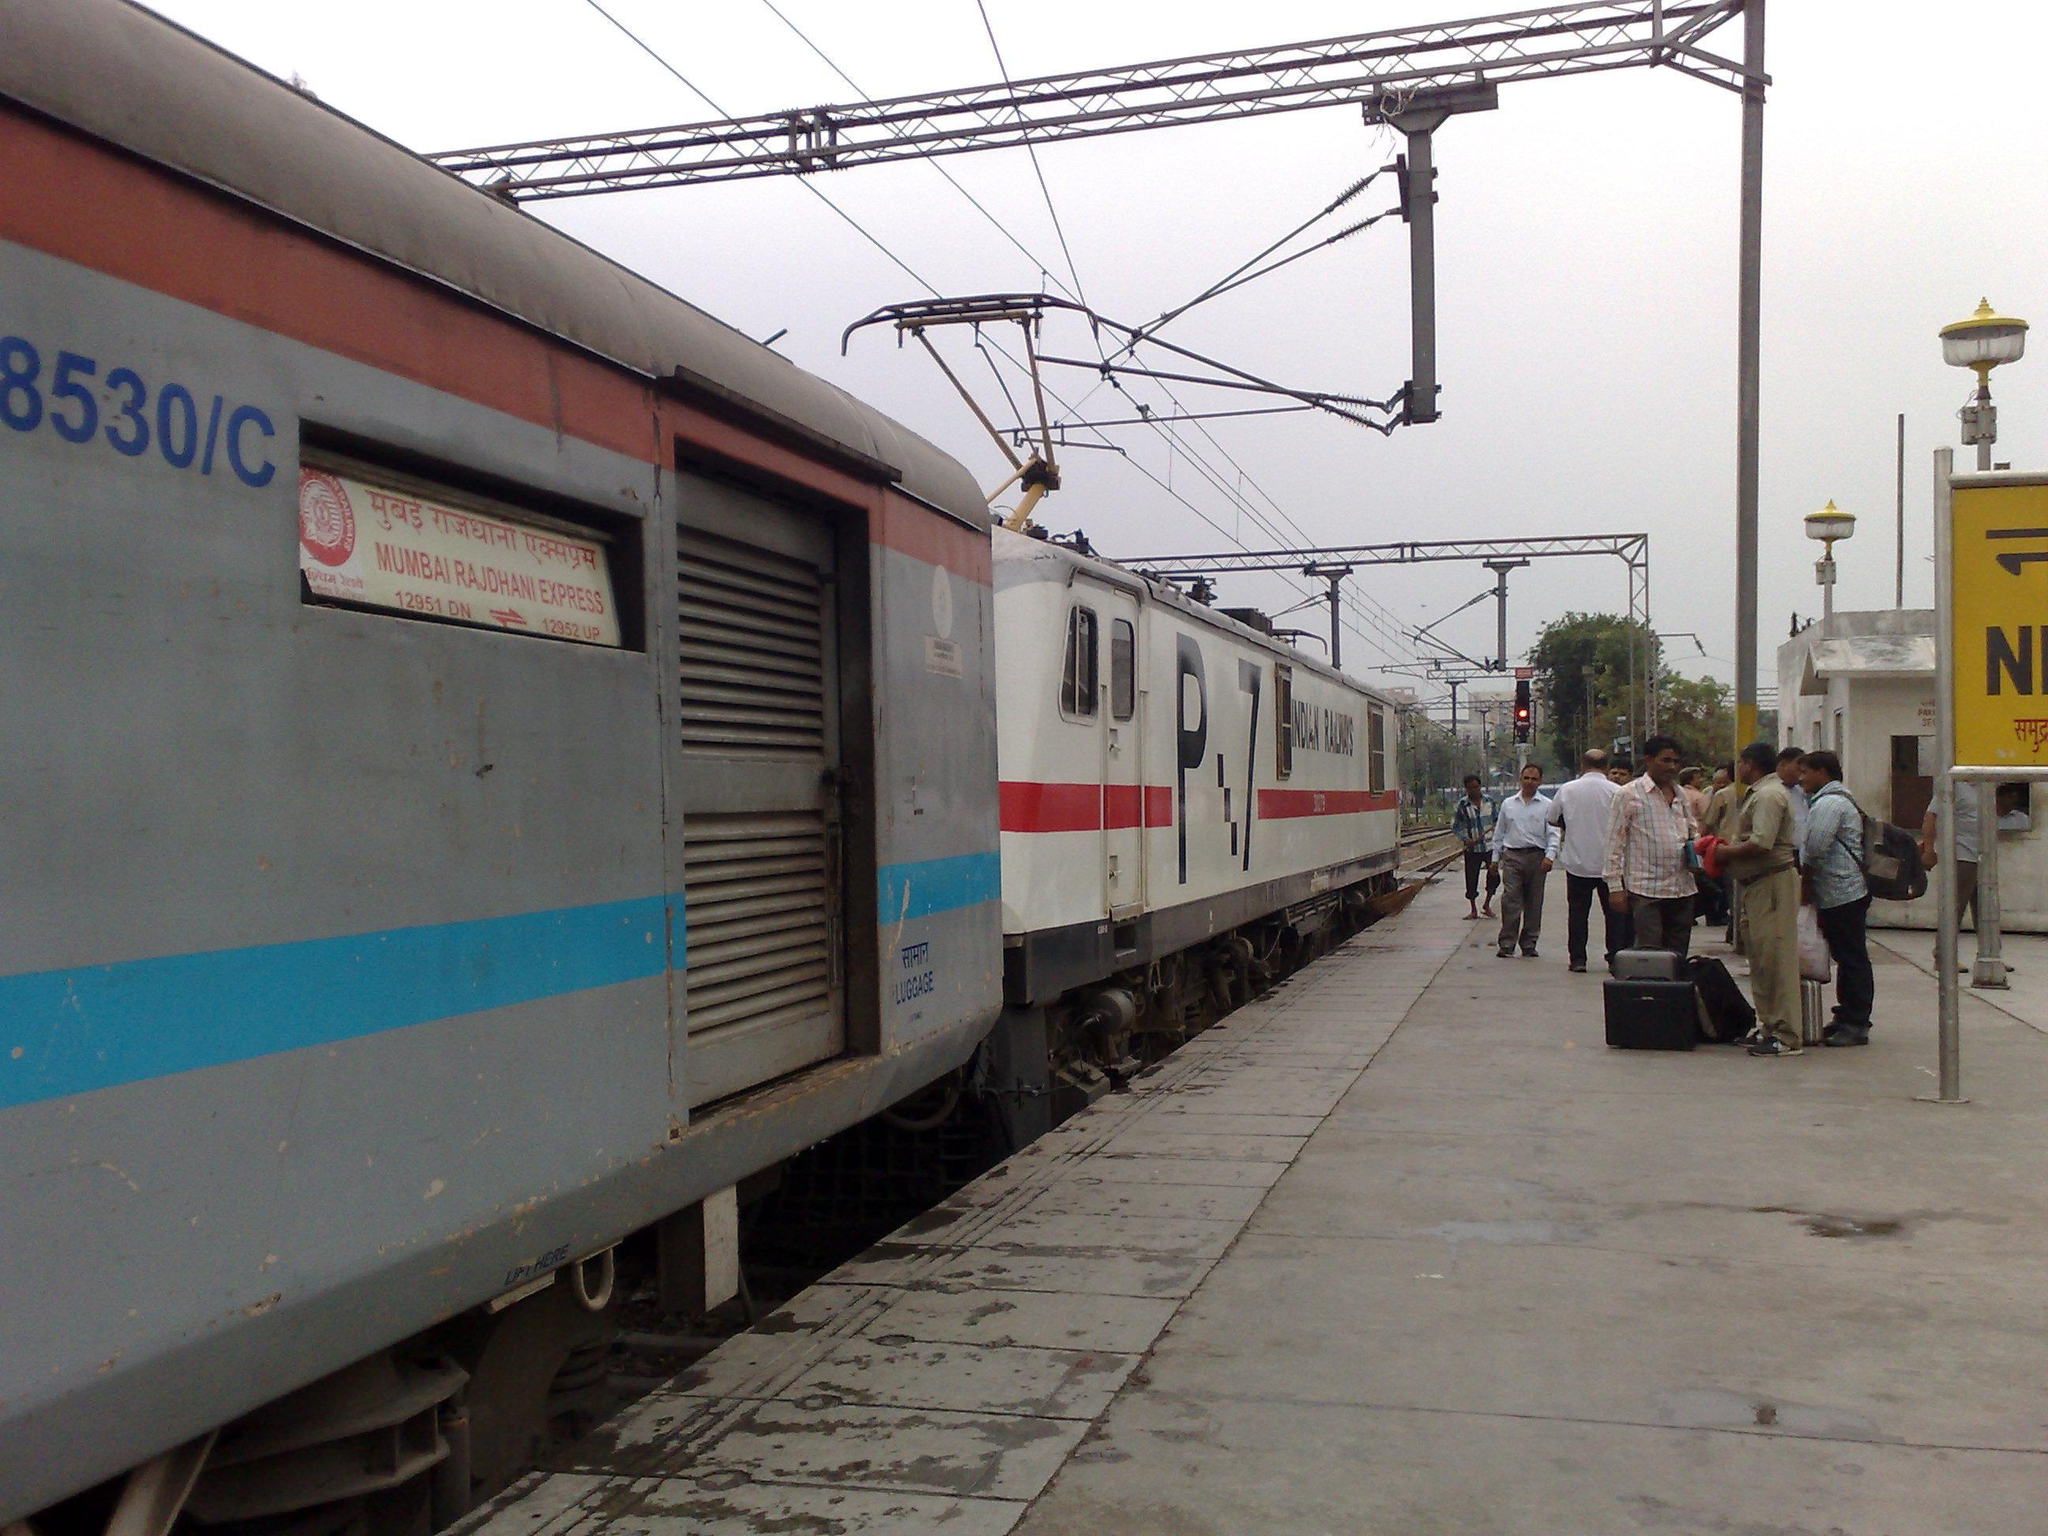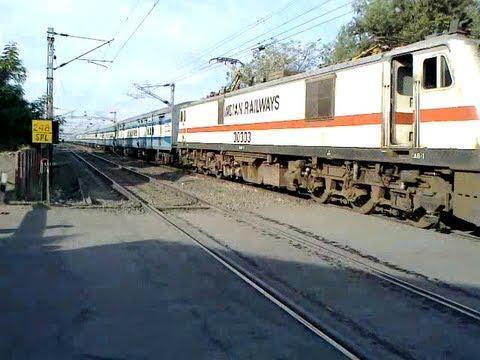The first image is the image on the left, the second image is the image on the right. Examine the images to the left and right. Is the description "Multiple people stand to one side of a train in one image, but no one is by the train in the other image, which angles rightward." accurate? Answer yes or no. Yes. The first image is the image on the left, the second image is the image on the right. For the images shown, is this caption "Several people are standing on the platform near the train in the image on the left." true? Answer yes or no. Yes. 